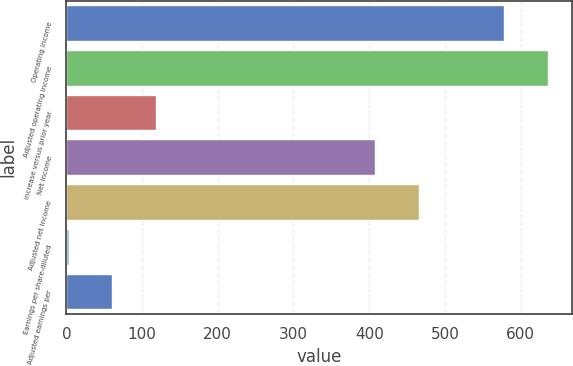Convert chart to OTSL. <chart><loc_0><loc_0><loc_500><loc_500><bar_chart><fcel>Operating income<fcel>Adjusted operating income<fcel>increase versus prior year<fcel>Net income<fcel>Adjusted net income<fcel>Earnings per share-diluted<fcel>Adjusted earnings per<nl><fcel>578.3<fcel>635.83<fcel>118.1<fcel>407.8<fcel>465.33<fcel>3.04<fcel>60.57<nl></chart> 